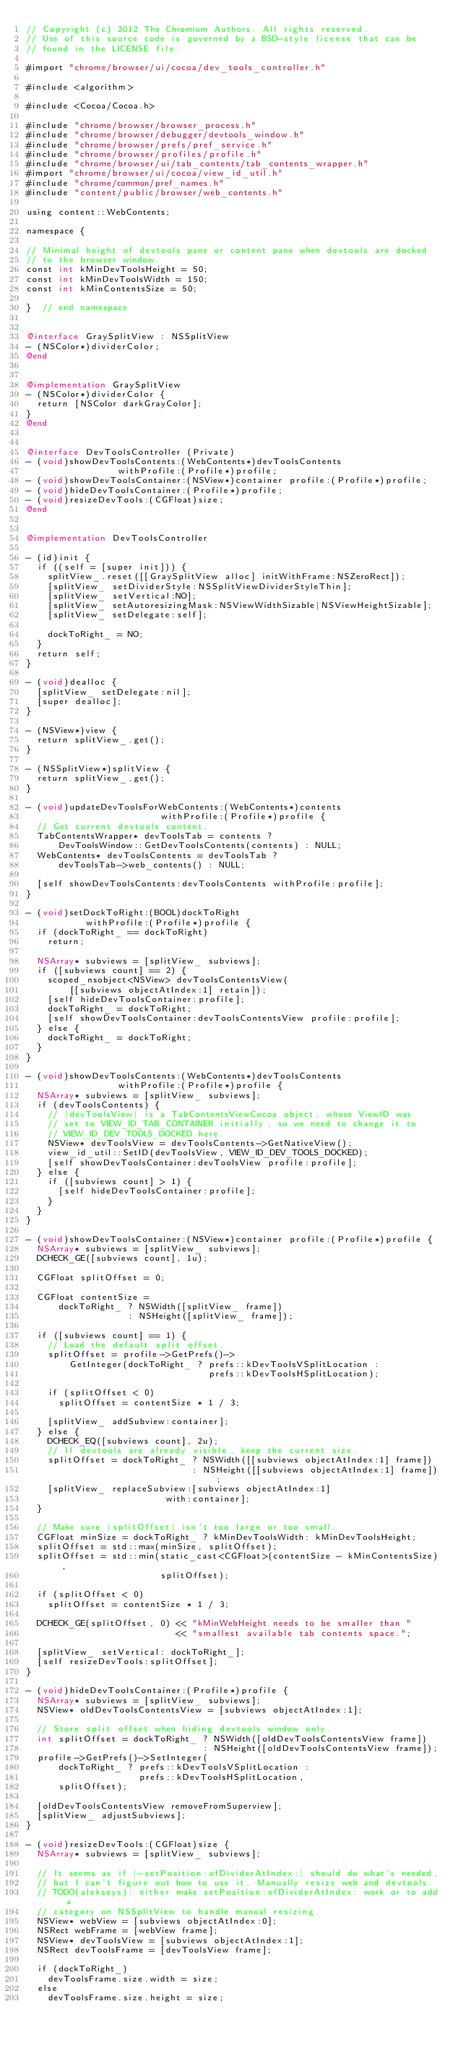<code> <loc_0><loc_0><loc_500><loc_500><_ObjectiveC_>// Copyright (c) 2012 The Chromium Authors. All rights reserved.
// Use of this source code is governed by a BSD-style license that can be
// found in the LICENSE file.

#import "chrome/browser/ui/cocoa/dev_tools_controller.h"

#include <algorithm>

#include <Cocoa/Cocoa.h>

#include "chrome/browser/browser_process.h"
#include "chrome/browser/debugger/devtools_window.h"
#include "chrome/browser/prefs/pref_service.h"
#include "chrome/browser/profiles/profile.h"
#include "chrome/browser/ui/tab_contents/tab_contents_wrapper.h"
#import "chrome/browser/ui/cocoa/view_id_util.h"
#include "chrome/common/pref_names.h"
#include "content/public/browser/web_contents.h"

using content::WebContents;

namespace {

// Minimal height of devtools pane or content pane when devtools are docked
// to the browser window.
const int kMinDevToolsHeight = 50;
const int kMinDevToolsWidth = 150;
const int kMinContentsSize = 50;

}  // end namespace


@interface GraySplitView : NSSplitView
- (NSColor*)dividerColor;
@end


@implementation GraySplitView
- (NSColor*)dividerColor {
  return [NSColor darkGrayColor];
}
@end


@interface DevToolsController (Private)
- (void)showDevToolsContents:(WebContents*)devToolsContents
                 withProfile:(Profile*)profile;
- (void)showDevToolsContainer:(NSView*)container profile:(Profile*)profile;
- (void)hideDevToolsContainer:(Profile*)profile;
- (void)resizeDevTools:(CGFloat)size;
@end


@implementation DevToolsController

- (id)init {
  if ((self = [super init])) {
    splitView_.reset([[GraySplitView alloc] initWithFrame:NSZeroRect]);
    [splitView_ setDividerStyle:NSSplitViewDividerStyleThin];
    [splitView_ setVertical:NO];
    [splitView_ setAutoresizingMask:NSViewWidthSizable|NSViewHeightSizable];
    [splitView_ setDelegate:self];

    dockToRight_ = NO;
  }
  return self;
}

- (void)dealloc {
  [splitView_ setDelegate:nil];
  [super dealloc];
}

- (NSView*)view {
  return splitView_.get();
}

- (NSSplitView*)splitView {
  return splitView_.get();
}

- (void)updateDevToolsForWebContents:(WebContents*)contents
                         withProfile:(Profile*)profile {
  // Get current devtools content.
  TabContentsWrapper* devToolsTab = contents ?
      DevToolsWindow::GetDevToolsContents(contents) : NULL;
  WebContents* devToolsContents = devToolsTab ?
      devToolsTab->web_contents() : NULL;

  [self showDevToolsContents:devToolsContents withProfile:profile];
}

- (void)setDockToRight:(BOOL)dockToRight
           withProfile:(Profile*)profile {
  if (dockToRight_ == dockToRight)
    return;

  NSArray* subviews = [splitView_ subviews];
  if ([subviews count] == 2) {
    scoped_nsobject<NSView> devToolsContentsView(
        [[subviews objectAtIndex:1] retain]);
    [self hideDevToolsContainer:profile];
    dockToRight_ = dockToRight;
    [self showDevToolsContainer:devToolsContentsView profile:profile];
  } else {
    dockToRight_ = dockToRight;
  }
}

- (void)showDevToolsContents:(WebContents*)devToolsContents
                 withProfile:(Profile*)profile {
  NSArray* subviews = [splitView_ subviews];
  if (devToolsContents) {
    // |devToolsView| is a TabContentsViewCocoa object, whose ViewID was
    // set to VIEW_ID_TAB_CONTAINER initially, so we need to change it to
    // VIEW_ID_DEV_TOOLS_DOCKED here.
    NSView* devToolsView = devToolsContents->GetNativeView();
    view_id_util::SetID(devToolsView, VIEW_ID_DEV_TOOLS_DOCKED);
    [self showDevToolsContainer:devToolsView profile:profile];
  } else {
    if ([subviews count] > 1) {
      [self hideDevToolsContainer:profile];
    }
  }
}

- (void)showDevToolsContainer:(NSView*)container profile:(Profile*)profile {
  NSArray* subviews = [splitView_ subviews];
  DCHECK_GE([subviews count], 1u);

  CGFloat splitOffset = 0;

  CGFloat contentSize =
      dockToRight_ ? NSWidth([splitView_ frame])
                   : NSHeight([splitView_ frame]);

  if ([subviews count] == 1) {
    // Load the default split offset.
    splitOffset = profile->GetPrefs()->
        GetInteger(dockToRight_ ? prefs::kDevToolsVSplitLocation :
                                  prefs::kDevToolsHSplitLocation);

    if (splitOffset < 0)
      splitOffset = contentSize * 1 / 3;

    [splitView_ addSubview:container];
  } else {
    DCHECK_EQ([subviews count], 2u);
    // If devtools are already visible, keep the current size.
    splitOffset = dockToRight_ ? NSWidth([[subviews objectAtIndex:1] frame])
                               : NSHeight([[subviews objectAtIndex:1] frame]);
    [splitView_ replaceSubview:[subviews objectAtIndex:1]
                          with:container];
  }

  // Make sure |splitOffset| isn't too large or too small.
  CGFloat minSize = dockToRight_ ? kMinDevToolsWidth: kMinDevToolsHeight;
  splitOffset = std::max(minSize, splitOffset);
  splitOffset = std::min(static_cast<CGFloat>(contentSize - kMinContentsSize),
                         splitOffset);

  if (splitOffset < 0)
    splitOffset = contentSize * 1 / 3;

  DCHECK_GE(splitOffset, 0) << "kMinWebHeight needs to be smaller than "
                            << "smallest available tab contents space.";

  [splitView_ setVertical: dockToRight_];
  [self resizeDevTools:splitOffset];
}

- (void)hideDevToolsContainer:(Profile*)profile {
  NSArray* subviews = [splitView_ subviews];
  NSView* oldDevToolsContentsView = [subviews objectAtIndex:1];

  // Store split offset when hiding devtools window only.
  int splitOffset = dockToRight_ ? NSWidth([oldDevToolsContentsView frame])
                                 : NSHeight([oldDevToolsContentsView frame]);
  profile->GetPrefs()->SetInteger(
      dockToRight_ ? prefs::kDevToolsVSplitLocation :
                     prefs::kDevToolsHSplitLocation,
      splitOffset);

  [oldDevToolsContentsView removeFromSuperview];
  [splitView_ adjustSubviews];
}

- (void)resizeDevTools:(CGFloat)size {
  NSArray* subviews = [splitView_ subviews];

  // It seems as if |-setPosition:ofDividerAtIndex:| should do what's needed,
  // but I can't figure out how to use it. Manually resize web and devtools.
  // TODO(alekseys): either make setPosition:ofDividerAtIndex: work or to add a
  // category on NSSplitView to handle manual resizing.
  NSView* webView = [subviews objectAtIndex:0];
  NSRect webFrame = [webView frame];
  NSView* devToolsView = [subviews objectAtIndex:1];
  NSRect devToolsFrame = [devToolsView frame];

  if (dockToRight_)
    devToolsFrame.size.width = size;
  else
    devToolsFrame.size.height = size;
</code> 